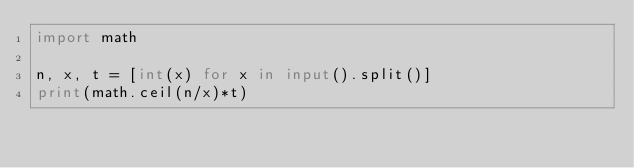<code> <loc_0><loc_0><loc_500><loc_500><_Python_>import math

n, x, t = [int(x) for x in input().split()]
print(math.ceil(n/x)*t)
</code> 